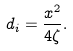<formula> <loc_0><loc_0><loc_500><loc_500>d _ { i } = \frac { x ^ { 2 } } { 4 \zeta } .</formula> 